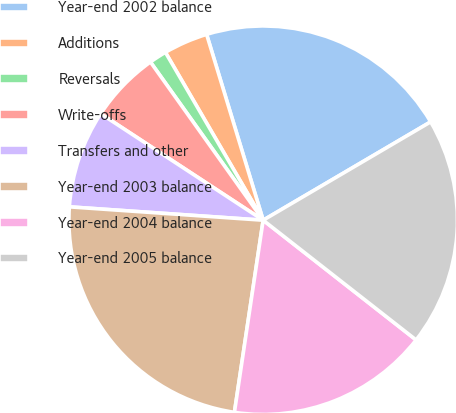<chart> <loc_0><loc_0><loc_500><loc_500><pie_chart><fcel>Year-end 2002 balance<fcel>Additions<fcel>Reversals<fcel>Write-offs<fcel>Transfers and other<fcel>Year-end 2003 balance<fcel>Year-end 2004 balance<fcel>Year-end 2005 balance<nl><fcel>21.25%<fcel>3.69%<fcel>1.46%<fcel>5.91%<fcel>8.14%<fcel>23.73%<fcel>16.79%<fcel>19.02%<nl></chart> 